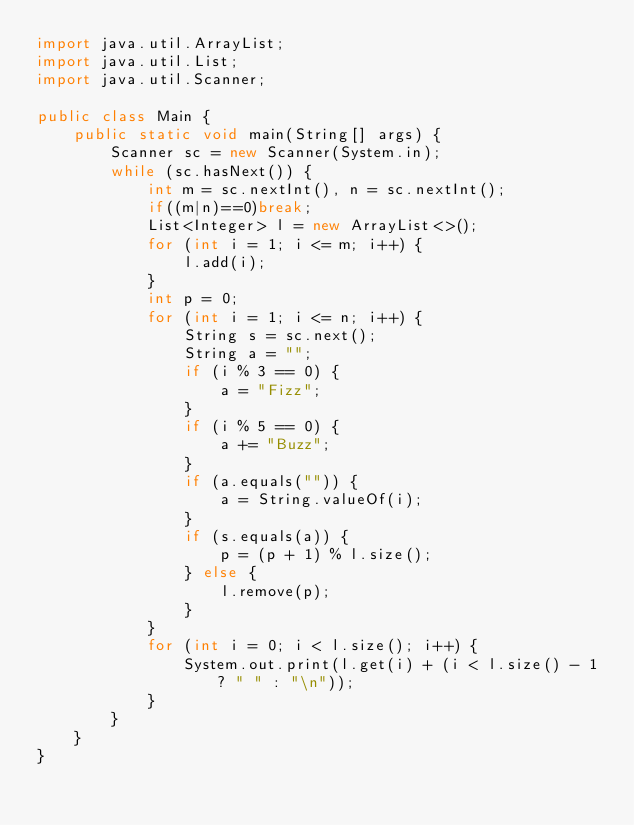Convert code to text. <code><loc_0><loc_0><loc_500><loc_500><_Java_>import java.util.ArrayList;
import java.util.List;
import java.util.Scanner;

public class Main {
    public static void main(String[] args) {
        Scanner sc = new Scanner(System.in);
        while (sc.hasNext()) {
            int m = sc.nextInt(), n = sc.nextInt();
            if((m|n)==0)break;
            List<Integer> l = new ArrayList<>();
            for (int i = 1; i <= m; i++) {
                l.add(i);
            }
            int p = 0;
            for (int i = 1; i <= n; i++) {
                String s = sc.next();
                String a = "";
                if (i % 3 == 0) {
                    a = "Fizz";
                }
                if (i % 5 == 0) {
                    a += "Buzz";
                }
                if (a.equals("")) {
                    a = String.valueOf(i);
                }
                if (s.equals(a)) {
                    p = (p + 1) % l.size();
                } else {
                    l.remove(p);
                }
            }
            for (int i = 0; i < l.size(); i++) {
                System.out.print(l.get(i) + (i < l.size() - 1 ? " " : "\n"));
            }
        }
    }
}
</code> 